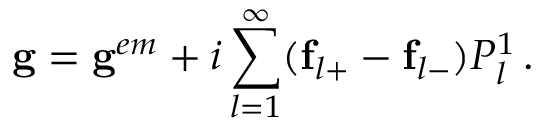Convert formula to latex. <formula><loc_0><loc_0><loc_500><loc_500>g = g ^ { e m } + i \sum _ { l = 1 } ^ { \infty } ( f _ { l + } - f _ { l - } ) P _ { l } ^ { 1 } \, .</formula> 